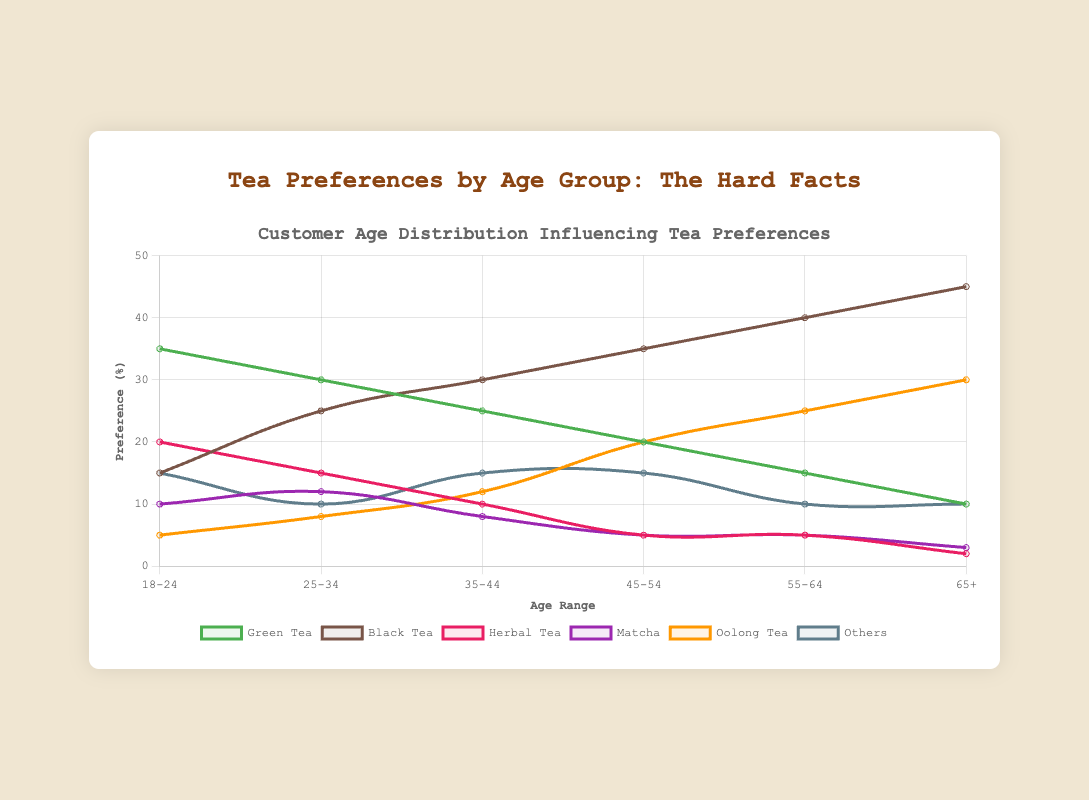What's the most preferred tea type among customers aged 65 and older? Look at the 65+ group, observing the highest data point. Black Tea has a preference percentage of 45%, which is the highest among all tea types in that age group.
Answer: Black Tea Which tea type sees the most significant increase in preference from the 18-24 to the 25-34 age group? Compare the data differences between the 18-24 and 25-34 age groups for each tea type. Green Tea drops by 5%, Black Tea increases by 10%, Herbal Tea drops by 5%, Matcha increases by 2%, Oolong Tea increases by 3%, and Others decrease by 5%. The most significant increase is seen in Black Tea, which rises by 10%.
Answer: Black Tea What is the total preference percentage for Green Tea and Matcha among customers aged 35-44? Sum up the preference percentages of Green Tea and Matcha in the 35-44 age group: 25% (Green Tea) + 8% (Matcha) = 33%.
Answer: 33% Does Black Tea preference increase or decrease with age? Observe the trend line for Black Tea across all age groups. The preference for Black Tea consistently increases from the 18-24 group at 15% to the 65+ group at 45%.
Answer: Increase How does the preference for Herbal Tea change from the age group 18-24 to 65+? Examine the data trend for Herbal Tea across age groups. Starting at 20% for 18-24 and decreasing gradually to 2% for 65+, the preference shows a clear decline.
Answer: Decreases Which age group has the highest preference for Oolong Tea? Review the Oolong Tea data points across all age groups. The highest preference is in the 65+ age group at 30%.
Answer: 65+ What's the average preference percentage for Black Tea across all age groups? Sum the Black Tea preference percentages for all age groups: 15% + 25% + 30% + 35% + 40% + 45% = 190%. Then, divide by the number of age groups (6): 190% / 6 ≈ 31.67%.
Answer: 31.67% Is the preference for Matcha higher in the 25-34 age group or the 55-64 age group? Compare the Matcha preference percentages for these two age groups. The 25-34 group prefers Matcha at 12%, while the 55-64 group prefers it at 5%.
Answer: 25-34 age group What is the combined total preference percentage for all tea types except 'Others' in the 45-54 age group? Add the preference percentages for Green Tea, Black Tea, Herbal Tea, Matcha, and Oolong Tea in the 45-54 age group: 20% + 35% + 5% + 5% + 20% = 85%.
Answer: 85% Which tea type has a preference percentage closest to 15% among the 55-64 age group? Compare all the tea type percentages with 15% in the 55-64 age group. Green Tea at 15% matches exactly to 15%.
Answer: Green Tea 